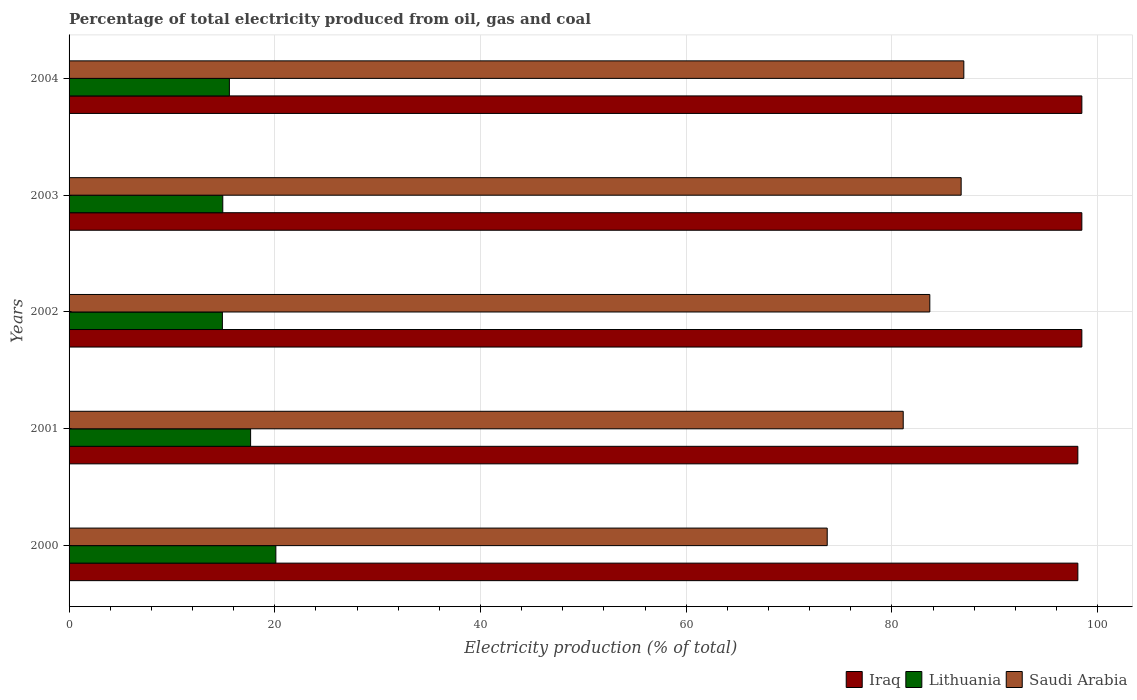How many groups of bars are there?
Offer a very short reply. 5. Are the number of bars on each tick of the Y-axis equal?
Keep it short and to the point. Yes. How many bars are there on the 5th tick from the top?
Offer a very short reply. 3. How many bars are there on the 5th tick from the bottom?
Ensure brevity in your answer.  3. What is the label of the 1st group of bars from the top?
Offer a terse response. 2004. What is the electricity production in in Iraq in 2003?
Provide a succinct answer. 98.47. Across all years, what is the maximum electricity production in in Saudi Arabia?
Give a very brief answer. 87. Across all years, what is the minimum electricity production in in Lithuania?
Make the answer very short. 14.91. In which year was the electricity production in in Lithuania maximum?
Make the answer very short. 2000. What is the total electricity production in in Lithuania in the graph?
Provide a succinct answer. 83.2. What is the difference between the electricity production in in Saudi Arabia in 2000 and that in 2004?
Provide a succinct answer. -13.28. What is the difference between the electricity production in in Iraq in 2004 and the electricity production in in Saudi Arabia in 2000?
Your answer should be compact. 24.76. What is the average electricity production in in Iraq per year?
Give a very brief answer. 98.32. In the year 2001, what is the difference between the electricity production in in Lithuania and electricity production in in Iraq?
Provide a short and direct response. -80.43. What is the ratio of the electricity production in in Saudi Arabia in 2001 to that in 2002?
Offer a very short reply. 0.97. Is the electricity production in in Saudi Arabia in 2002 less than that in 2003?
Your answer should be very brief. Yes. What is the difference between the highest and the second highest electricity production in in Saudi Arabia?
Your answer should be compact. 0.26. What is the difference between the highest and the lowest electricity production in in Iraq?
Provide a short and direct response. 0.39. What does the 1st bar from the top in 2002 represents?
Make the answer very short. Saudi Arabia. What does the 3rd bar from the bottom in 2001 represents?
Keep it short and to the point. Saudi Arabia. Is it the case that in every year, the sum of the electricity production in in Saudi Arabia and electricity production in in Iraq is greater than the electricity production in in Lithuania?
Ensure brevity in your answer.  Yes. Are all the bars in the graph horizontal?
Give a very brief answer. Yes. What is the difference between two consecutive major ticks on the X-axis?
Keep it short and to the point. 20. Are the values on the major ticks of X-axis written in scientific E-notation?
Offer a very short reply. No. Does the graph contain any zero values?
Ensure brevity in your answer.  No. Does the graph contain grids?
Provide a succinct answer. Yes. Where does the legend appear in the graph?
Your response must be concise. Bottom right. How many legend labels are there?
Offer a very short reply. 3. What is the title of the graph?
Provide a short and direct response. Percentage of total electricity produced from oil, gas and coal. Does "Slovenia" appear as one of the legend labels in the graph?
Offer a terse response. No. What is the label or title of the X-axis?
Your response must be concise. Electricity production (% of total). What is the Electricity production (% of total) of Iraq in 2000?
Your response must be concise. 98.08. What is the Electricity production (% of total) of Lithuania in 2000?
Provide a succinct answer. 20.11. What is the Electricity production (% of total) of Saudi Arabia in 2000?
Give a very brief answer. 73.72. What is the Electricity production (% of total) in Iraq in 2001?
Your answer should be compact. 98.08. What is the Electricity production (% of total) of Lithuania in 2001?
Give a very brief answer. 17.65. What is the Electricity production (% of total) in Saudi Arabia in 2001?
Ensure brevity in your answer.  81.11. What is the Electricity production (% of total) in Iraq in 2002?
Keep it short and to the point. 98.47. What is the Electricity production (% of total) of Lithuania in 2002?
Your answer should be compact. 14.91. What is the Electricity production (% of total) of Saudi Arabia in 2002?
Provide a short and direct response. 83.69. What is the Electricity production (% of total) in Iraq in 2003?
Your response must be concise. 98.47. What is the Electricity production (% of total) in Lithuania in 2003?
Ensure brevity in your answer.  14.95. What is the Electricity production (% of total) in Saudi Arabia in 2003?
Keep it short and to the point. 86.74. What is the Electricity production (% of total) of Iraq in 2004?
Provide a short and direct response. 98.47. What is the Electricity production (% of total) of Lithuania in 2004?
Your response must be concise. 15.59. What is the Electricity production (% of total) in Saudi Arabia in 2004?
Provide a short and direct response. 87. Across all years, what is the maximum Electricity production (% of total) of Iraq?
Your answer should be compact. 98.47. Across all years, what is the maximum Electricity production (% of total) of Lithuania?
Ensure brevity in your answer.  20.11. Across all years, what is the maximum Electricity production (% of total) in Saudi Arabia?
Ensure brevity in your answer.  87. Across all years, what is the minimum Electricity production (% of total) of Iraq?
Your answer should be compact. 98.08. Across all years, what is the minimum Electricity production (% of total) in Lithuania?
Your answer should be very brief. 14.91. Across all years, what is the minimum Electricity production (% of total) of Saudi Arabia?
Make the answer very short. 73.72. What is the total Electricity production (% of total) in Iraq in the graph?
Your answer should be compact. 491.59. What is the total Electricity production (% of total) of Lithuania in the graph?
Provide a succinct answer. 83.2. What is the total Electricity production (% of total) of Saudi Arabia in the graph?
Ensure brevity in your answer.  412.25. What is the difference between the Electricity production (% of total) of Iraq in 2000 and that in 2001?
Offer a very short reply. 0. What is the difference between the Electricity production (% of total) of Lithuania in 2000 and that in 2001?
Offer a very short reply. 2.46. What is the difference between the Electricity production (% of total) of Saudi Arabia in 2000 and that in 2001?
Keep it short and to the point. -7.39. What is the difference between the Electricity production (% of total) in Iraq in 2000 and that in 2002?
Ensure brevity in your answer.  -0.39. What is the difference between the Electricity production (% of total) in Lithuania in 2000 and that in 2002?
Your answer should be very brief. 5.2. What is the difference between the Electricity production (% of total) in Saudi Arabia in 2000 and that in 2002?
Offer a terse response. -9.98. What is the difference between the Electricity production (% of total) of Iraq in 2000 and that in 2003?
Provide a short and direct response. -0.39. What is the difference between the Electricity production (% of total) in Lithuania in 2000 and that in 2003?
Make the answer very short. 5.16. What is the difference between the Electricity production (% of total) of Saudi Arabia in 2000 and that in 2003?
Ensure brevity in your answer.  -13.02. What is the difference between the Electricity production (% of total) in Iraq in 2000 and that in 2004?
Make the answer very short. -0.39. What is the difference between the Electricity production (% of total) of Lithuania in 2000 and that in 2004?
Offer a terse response. 4.52. What is the difference between the Electricity production (% of total) in Saudi Arabia in 2000 and that in 2004?
Keep it short and to the point. -13.28. What is the difference between the Electricity production (% of total) of Iraq in 2001 and that in 2002?
Your answer should be compact. -0.39. What is the difference between the Electricity production (% of total) of Lithuania in 2001 and that in 2002?
Give a very brief answer. 2.74. What is the difference between the Electricity production (% of total) in Saudi Arabia in 2001 and that in 2002?
Provide a succinct answer. -2.59. What is the difference between the Electricity production (% of total) in Iraq in 2001 and that in 2003?
Keep it short and to the point. -0.39. What is the difference between the Electricity production (% of total) of Lithuania in 2001 and that in 2003?
Provide a succinct answer. 2.7. What is the difference between the Electricity production (% of total) in Saudi Arabia in 2001 and that in 2003?
Make the answer very short. -5.63. What is the difference between the Electricity production (% of total) in Iraq in 2001 and that in 2004?
Your response must be concise. -0.39. What is the difference between the Electricity production (% of total) of Lithuania in 2001 and that in 2004?
Give a very brief answer. 2.06. What is the difference between the Electricity production (% of total) of Saudi Arabia in 2001 and that in 2004?
Offer a very short reply. -5.89. What is the difference between the Electricity production (% of total) in Iraq in 2002 and that in 2003?
Your answer should be compact. 0. What is the difference between the Electricity production (% of total) of Lithuania in 2002 and that in 2003?
Keep it short and to the point. -0.04. What is the difference between the Electricity production (% of total) in Saudi Arabia in 2002 and that in 2003?
Offer a very short reply. -3.05. What is the difference between the Electricity production (% of total) of Iraq in 2002 and that in 2004?
Ensure brevity in your answer.  -0. What is the difference between the Electricity production (% of total) of Lithuania in 2002 and that in 2004?
Your response must be concise. -0.68. What is the difference between the Electricity production (% of total) of Saudi Arabia in 2002 and that in 2004?
Offer a terse response. -3.31. What is the difference between the Electricity production (% of total) in Iraq in 2003 and that in 2004?
Your answer should be very brief. -0. What is the difference between the Electricity production (% of total) of Lithuania in 2003 and that in 2004?
Offer a terse response. -0.64. What is the difference between the Electricity production (% of total) in Saudi Arabia in 2003 and that in 2004?
Your response must be concise. -0.26. What is the difference between the Electricity production (% of total) of Iraq in 2000 and the Electricity production (% of total) of Lithuania in 2001?
Offer a very short reply. 80.43. What is the difference between the Electricity production (% of total) in Iraq in 2000 and the Electricity production (% of total) in Saudi Arabia in 2001?
Provide a short and direct response. 16.98. What is the difference between the Electricity production (% of total) of Lithuania in 2000 and the Electricity production (% of total) of Saudi Arabia in 2001?
Your answer should be very brief. -61. What is the difference between the Electricity production (% of total) in Iraq in 2000 and the Electricity production (% of total) in Lithuania in 2002?
Your response must be concise. 83.18. What is the difference between the Electricity production (% of total) in Iraq in 2000 and the Electricity production (% of total) in Saudi Arabia in 2002?
Offer a very short reply. 14.39. What is the difference between the Electricity production (% of total) in Lithuania in 2000 and the Electricity production (% of total) in Saudi Arabia in 2002?
Keep it short and to the point. -63.58. What is the difference between the Electricity production (% of total) in Iraq in 2000 and the Electricity production (% of total) in Lithuania in 2003?
Your answer should be compact. 83.14. What is the difference between the Electricity production (% of total) of Iraq in 2000 and the Electricity production (% of total) of Saudi Arabia in 2003?
Provide a short and direct response. 11.35. What is the difference between the Electricity production (% of total) in Lithuania in 2000 and the Electricity production (% of total) in Saudi Arabia in 2003?
Provide a short and direct response. -66.63. What is the difference between the Electricity production (% of total) in Iraq in 2000 and the Electricity production (% of total) in Lithuania in 2004?
Offer a terse response. 82.5. What is the difference between the Electricity production (% of total) in Iraq in 2000 and the Electricity production (% of total) in Saudi Arabia in 2004?
Ensure brevity in your answer.  11.09. What is the difference between the Electricity production (% of total) of Lithuania in 2000 and the Electricity production (% of total) of Saudi Arabia in 2004?
Keep it short and to the point. -66.89. What is the difference between the Electricity production (% of total) in Iraq in 2001 and the Electricity production (% of total) in Lithuania in 2002?
Offer a very short reply. 83.18. What is the difference between the Electricity production (% of total) in Iraq in 2001 and the Electricity production (% of total) in Saudi Arabia in 2002?
Offer a very short reply. 14.39. What is the difference between the Electricity production (% of total) of Lithuania in 2001 and the Electricity production (% of total) of Saudi Arabia in 2002?
Offer a terse response. -66.04. What is the difference between the Electricity production (% of total) of Iraq in 2001 and the Electricity production (% of total) of Lithuania in 2003?
Your answer should be compact. 83.14. What is the difference between the Electricity production (% of total) of Iraq in 2001 and the Electricity production (% of total) of Saudi Arabia in 2003?
Your answer should be very brief. 11.35. What is the difference between the Electricity production (% of total) in Lithuania in 2001 and the Electricity production (% of total) in Saudi Arabia in 2003?
Ensure brevity in your answer.  -69.09. What is the difference between the Electricity production (% of total) of Iraq in 2001 and the Electricity production (% of total) of Lithuania in 2004?
Give a very brief answer. 82.5. What is the difference between the Electricity production (% of total) in Iraq in 2001 and the Electricity production (% of total) in Saudi Arabia in 2004?
Your answer should be compact. 11.09. What is the difference between the Electricity production (% of total) in Lithuania in 2001 and the Electricity production (% of total) in Saudi Arabia in 2004?
Provide a short and direct response. -69.35. What is the difference between the Electricity production (% of total) of Iraq in 2002 and the Electricity production (% of total) of Lithuania in 2003?
Give a very brief answer. 83.53. What is the difference between the Electricity production (% of total) of Iraq in 2002 and the Electricity production (% of total) of Saudi Arabia in 2003?
Keep it short and to the point. 11.74. What is the difference between the Electricity production (% of total) in Lithuania in 2002 and the Electricity production (% of total) in Saudi Arabia in 2003?
Your response must be concise. -71.83. What is the difference between the Electricity production (% of total) in Iraq in 2002 and the Electricity production (% of total) in Lithuania in 2004?
Your answer should be very brief. 82.89. What is the difference between the Electricity production (% of total) in Iraq in 2002 and the Electricity production (% of total) in Saudi Arabia in 2004?
Ensure brevity in your answer.  11.48. What is the difference between the Electricity production (% of total) in Lithuania in 2002 and the Electricity production (% of total) in Saudi Arabia in 2004?
Give a very brief answer. -72.09. What is the difference between the Electricity production (% of total) in Iraq in 2003 and the Electricity production (% of total) in Lithuania in 2004?
Provide a succinct answer. 82.88. What is the difference between the Electricity production (% of total) in Iraq in 2003 and the Electricity production (% of total) in Saudi Arabia in 2004?
Provide a succinct answer. 11.47. What is the difference between the Electricity production (% of total) in Lithuania in 2003 and the Electricity production (% of total) in Saudi Arabia in 2004?
Provide a short and direct response. -72.05. What is the average Electricity production (% of total) of Iraq per year?
Your answer should be very brief. 98.32. What is the average Electricity production (% of total) in Lithuania per year?
Offer a terse response. 16.64. What is the average Electricity production (% of total) of Saudi Arabia per year?
Keep it short and to the point. 82.45. In the year 2000, what is the difference between the Electricity production (% of total) in Iraq and Electricity production (% of total) in Lithuania?
Your response must be concise. 77.98. In the year 2000, what is the difference between the Electricity production (% of total) in Iraq and Electricity production (% of total) in Saudi Arabia?
Keep it short and to the point. 24.37. In the year 2000, what is the difference between the Electricity production (% of total) in Lithuania and Electricity production (% of total) in Saudi Arabia?
Offer a very short reply. -53.61. In the year 2001, what is the difference between the Electricity production (% of total) in Iraq and Electricity production (% of total) in Lithuania?
Offer a terse response. 80.43. In the year 2001, what is the difference between the Electricity production (% of total) of Iraq and Electricity production (% of total) of Saudi Arabia?
Offer a terse response. 16.98. In the year 2001, what is the difference between the Electricity production (% of total) in Lithuania and Electricity production (% of total) in Saudi Arabia?
Offer a very short reply. -63.45. In the year 2002, what is the difference between the Electricity production (% of total) of Iraq and Electricity production (% of total) of Lithuania?
Your answer should be compact. 83.57. In the year 2002, what is the difference between the Electricity production (% of total) in Iraq and Electricity production (% of total) in Saudi Arabia?
Keep it short and to the point. 14.78. In the year 2002, what is the difference between the Electricity production (% of total) in Lithuania and Electricity production (% of total) in Saudi Arabia?
Keep it short and to the point. -68.78. In the year 2003, what is the difference between the Electricity production (% of total) in Iraq and Electricity production (% of total) in Lithuania?
Your response must be concise. 83.53. In the year 2003, what is the difference between the Electricity production (% of total) of Iraq and Electricity production (% of total) of Saudi Arabia?
Give a very brief answer. 11.73. In the year 2003, what is the difference between the Electricity production (% of total) of Lithuania and Electricity production (% of total) of Saudi Arabia?
Offer a very short reply. -71.79. In the year 2004, what is the difference between the Electricity production (% of total) of Iraq and Electricity production (% of total) of Lithuania?
Make the answer very short. 82.89. In the year 2004, what is the difference between the Electricity production (% of total) of Iraq and Electricity production (% of total) of Saudi Arabia?
Your response must be concise. 11.48. In the year 2004, what is the difference between the Electricity production (% of total) of Lithuania and Electricity production (% of total) of Saudi Arabia?
Provide a succinct answer. -71.41. What is the ratio of the Electricity production (% of total) in Iraq in 2000 to that in 2001?
Provide a succinct answer. 1. What is the ratio of the Electricity production (% of total) of Lithuania in 2000 to that in 2001?
Offer a terse response. 1.14. What is the ratio of the Electricity production (% of total) of Saudi Arabia in 2000 to that in 2001?
Your answer should be very brief. 0.91. What is the ratio of the Electricity production (% of total) of Iraq in 2000 to that in 2002?
Provide a succinct answer. 1. What is the ratio of the Electricity production (% of total) in Lithuania in 2000 to that in 2002?
Offer a very short reply. 1.35. What is the ratio of the Electricity production (% of total) of Saudi Arabia in 2000 to that in 2002?
Ensure brevity in your answer.  0.88. What is the ratio of the Electricity production (% of total) of Lithuania in 2000 to that in 2003?
Keep it short and to the point. 1.35. What is the ratio of the Electricity production (% of total) in Saudi Arabia in 2000 to that in 2003?
Ensure brevity in your answer.  0.85. What is the ratio of the Electricity production (% of total) of Iraq in 2000 to that in 2004?
Ensure brevity in your answer.  1. What is the ratio of the Electricity production (% of total) of Lithuania in 2000 to that in 2004?
Your answer should be compact. 1.29. What is the ratio of the Electricity production (% of total) in Saudi Arabia in 2000 to that in 2004?
Your response must be concise. 0.85. What is the ratio of the Electricity production (% of total) in Iraq in 2001 to that in 2002?
Make the answer very short. 1. What is the ratio of the Electricity production (% of total) in Lithuania in 2001 to that in 2002?
Provide a succinct answer. 1.18. What is the ratio of the Electricity production (% of total) in Saudi Arabia in 2001 to that in 2002?
Ensure brevity in your answer.  0.97. What is the ratio of the Electricity production (% of total) in Lithuania in 2001 to that in 2003?
Give a very brief answer. 1.18. What is the ratio of the Electricity production (% of total) of Saudi Arabia in 2001 to that in 2003?
Your answer should be very brief. 0.94. What is the ratio of the Electricity production (% of total) in Lithuania in 2001 to that in 2004?
Give a very brief answer. 1.13. What is the ratio of the Electricity production (% of total) in Saudi Arabia in 2001 to that in 2004?
Your answer should be compact. 0.93. What is the ratio of the Electricity production (% of total) of Lithuania in 2002 to that in 2003?
Ensure brevity in your answer.  1. What is the ratio of the Electricity production (% of total) of Saudi Arabia in 2002 to that in 2003?
Make the answer very short. 0.96. What is the ratio of the Electricity production (% of total) of Lithuania in 2002 to that in 2004?
Keep it short and to the point. 0.96. What is the ratio of the Electricity production (% of total) in Saudi Arabia in 2002 to that in 2004?
Offer a very short reply. 0.96. What is the ratio of the Electricity production (% of total) in Iraq in 2003 to that in 2004?
Keep it short and to the point. 1. What is the ratio of the Electricity production (% of total) of Lithuania in 2003 to that in 2004?
Your answer should be very brief. 0.96. What is the ratio of the Electricity production (% of total) in Saudi Arabia in 2003 to that in 2004?
Ensure brevity in your answer.  1. What is the difference between the highest and the second highest Electricity production (% of total) in Iraq?
Your answer should be compact. 0. What is the difference between the highest and the second highest Electricity production (% of total) of Lithuania?
Give a very brief answer. 2.46. What is the difference between the highest and the second highest Electricity production (% of total) of Saudi Arabia?
Offer a very short reply. 0.26. What is the difference between the highest and the lowest Electricity production (% of total) in Iraq?
Offer a very short reply. 0.39. What is the difference between the highest and the lowest Electricity production (% of total) of Lithuania?
Keep it short and to the point. 5.2. What is the difference between the highest and the lowest Electricity production (% of total) of Saudi Arabia?
Provide a short and direct response. 13.28. 